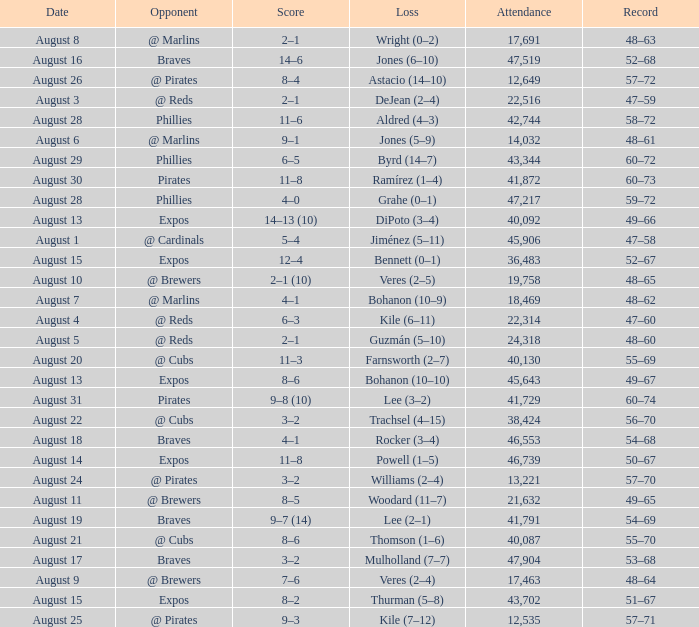What is the lowest attendance total on August 26? 12649.0. 